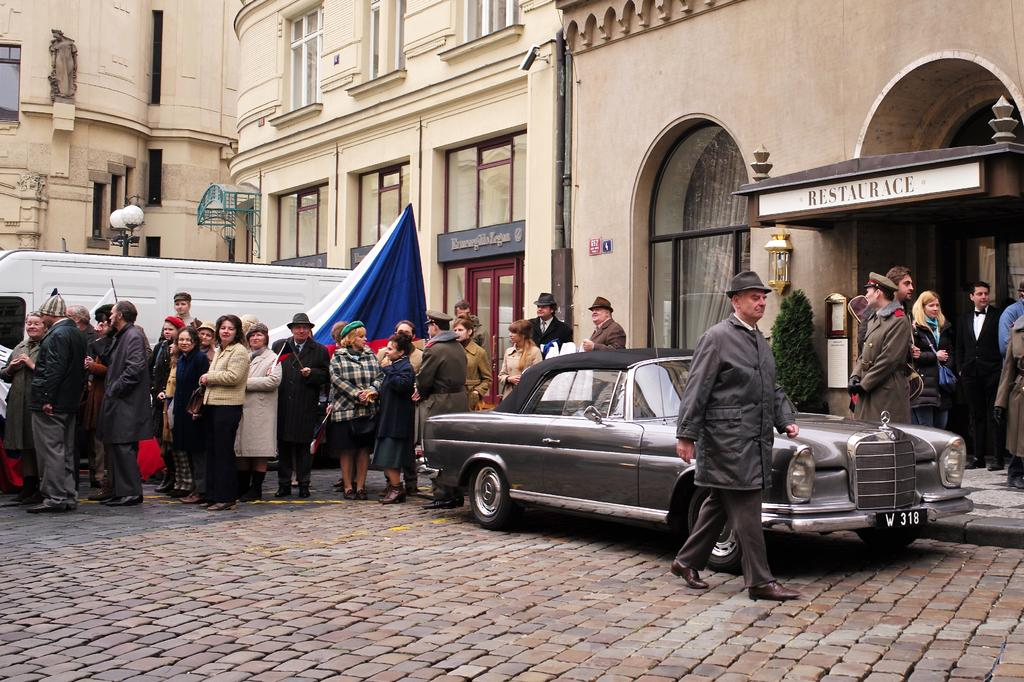What is the man in the image doing? The man is walking on the right side of the image. What else can be seen in the image besides the man? There is a car, people standing on the left side, and a building in the image. Where is the sofa located in the image? There is no sofa present in the image. Is the man wearing a crown while walking in the image? There is no crown visible in the image, and the man is not wearing one. 